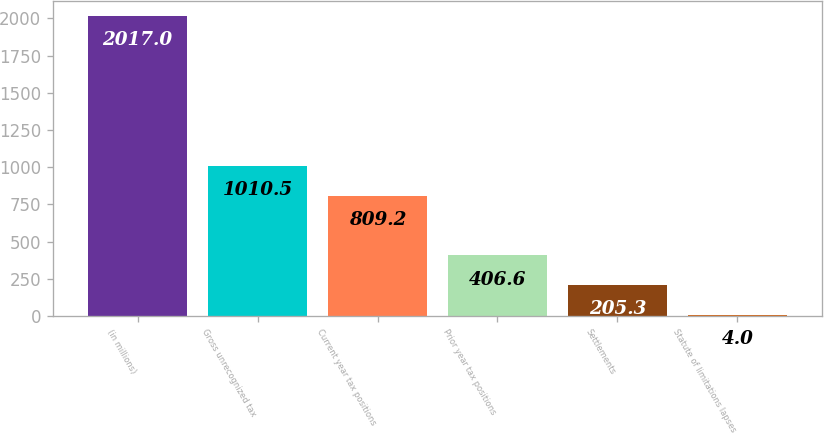Convert chart. <chart><loc_0><loc_0><loc_500><loc_500><bar_chart><fcel>(in millions)<fcel>Gross unrecognized tax<fcel>Current year tax positions<fcel>Prior year tax positions<fcel>Settlements<fcel>Statute of limitations lapses<nl><fcel>2017<fcel>1010.5<fcel>809.2<fcel>406.6<fcel>205.3<fcel>4<nl></chart> 